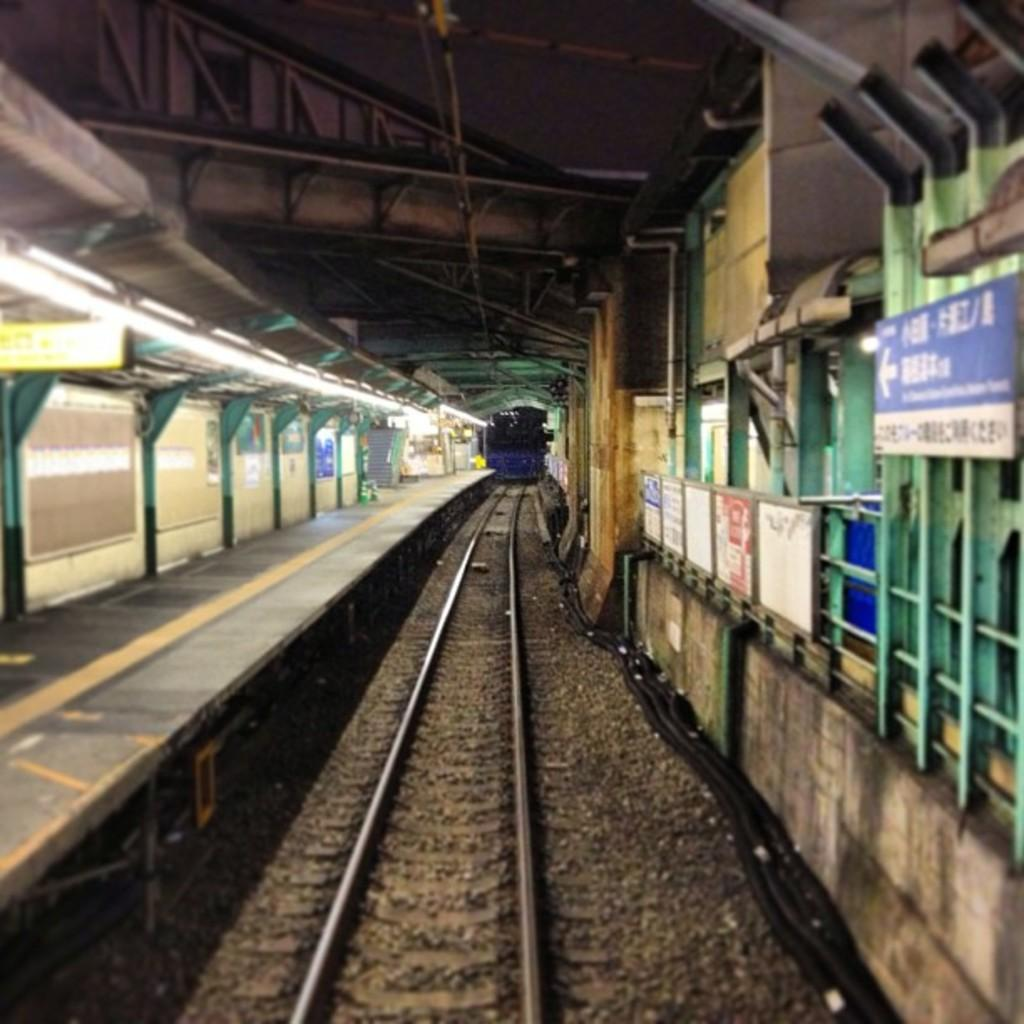What type of transportation infrastructure is present in the image? There is a railway track in the image. What is located near the railway track? There is a platform in the image. What can be seen providing illumination in the image? There are lights in the image. What type of structure is present in the image that supports the lights? There are boards attached to iron rods in the image. What type of rice can be seen growing near the railway track in the image? There is no rice present in the image; it features a railway track, platform, lights, and boards attached to iron rods. Can you see any spacecraft or astronauts in the image? There is no reference to spacecraft or astronauts in the image; it features a railway track, platform, lights, and boards attached to iron rods. 